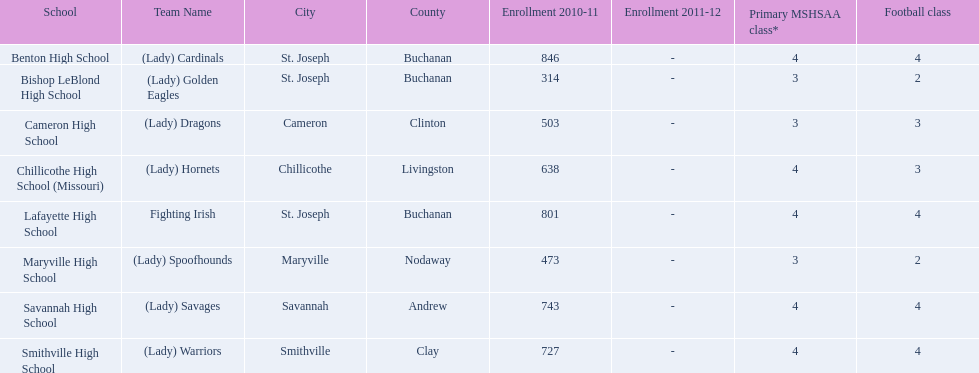How many teams are named after birds? 2. 